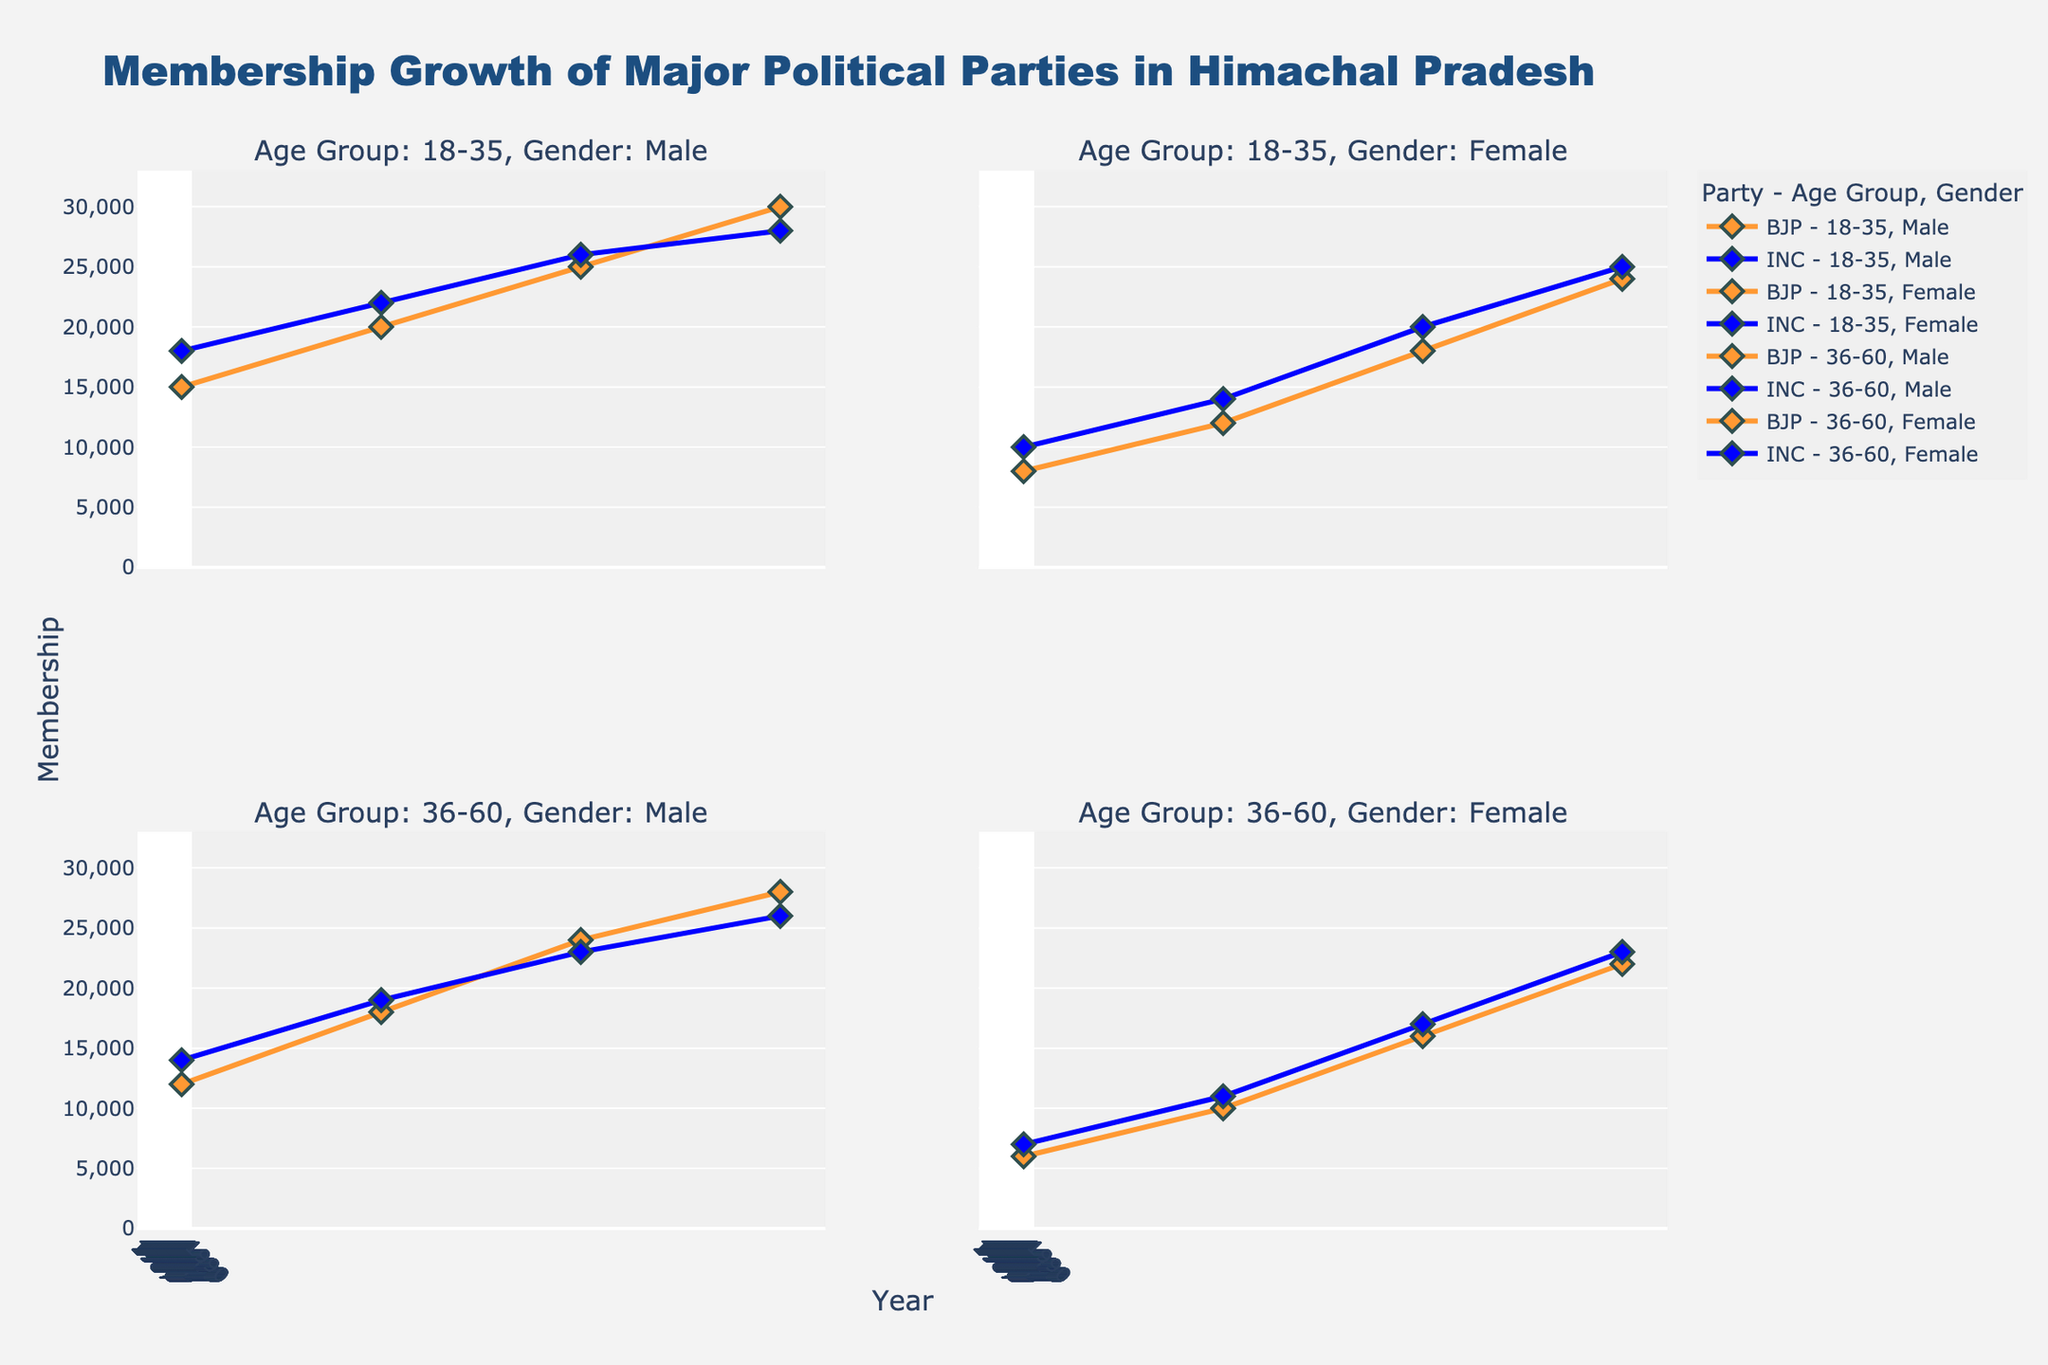What's the title of the chart? The title of the chart is given at the top center. By examining the visual, it's clear that the title reads "Membership Growth of Major Political Parties in Himachal Pradesh."
Answer: Membership Growth of Major Political Parties in Himachal Pradesh Which age group and gender segment has shown the most consistent growth for BJP? By examining each subplot for BJP segments, we see a consistent increase over the years. Particularly, the "18-35, Female" segment shows a steady growth across all plot points.
Answer: 18-35, Female In the age group 36-60, which gender had higher membership growth in urban areas for the INC in 2020? By analyzing the subplot with the age group 36-60 and looking at both male and female segments for the year 2020, we see that females had higher membership numbers.
Answer: Female How does the membership growth of the BJP in rural areas for 18-35 year old males compare between 2000 and 2010? Observing the subplot for "Age Group: 18-35, Gender: Male", we compare the two years' data points. The membership in 2000 is around 20,000, and in 2010 it increases to 25,000, showing an increase of 5,000 members.
Answer: It increased by 5,000 members What is the average membership growth for INC in the 36-60 age group for both genders in urban areas from 1990 to 2020? To find the average membership, observe the 36-60 age group, urban area for both males and females. The data points are: 
- Males: 14,000 (1990), 19,000 (2000), 23,000 (2010), 26,000 (2020).
- Females: 7,000 (1990), 11,000 (2000), 17,000 (2010), 23,000 (2020).
Summing these and dividing by the number of points:
Males: (14,000 + 19,000 + 23,000 + 26,000) / 4 = 20,500
Females: (7,000 + 11,000 + 17,000 + 23,000) / 4 = 14,500
Average: (20,500 + 14,500) / 2 = 17,500
Answer: 17,500 Which party had a higher membership in the 18-35, female, rural segment in 2000? Observing the "Age Group: 18-35, Gender: Female" in rural areas for the year 2000, we see the data points for BJP are at 12,000 and for INC at 14,000. Hence, INC had higher membership.
Answer: INC Between 1990 and 2020, which party showed a more significant increase in membership in the rural areas for 18-35 year old males? Examining the segments, the BJP's membership increased from 15,000 to 30,000, a growth of 15,000. The INC's membership grew from 18,000 to 28,000, a growth of 10,000. Thus, BJP had a more significant increase.
Answer: BJP In which year did the female members of 36-60 age group in urban areas for BJP reach 16,000? By looking at the subplot for "36-60, Female, Urban," we see that the BJP reached 16,000 members in the year 2010.
Answer: 2010 For the age group 18-35, in which year did the male rural members of INC equal male urban members of BJP's 36-60 age group? By comparing the subplots for the given segments, we find that the INC male rural members for 18-35 were 22,000 in the year 2000, which is the same as the BJP male urban members for 36-60 also in 2000.
Answer: 2000 